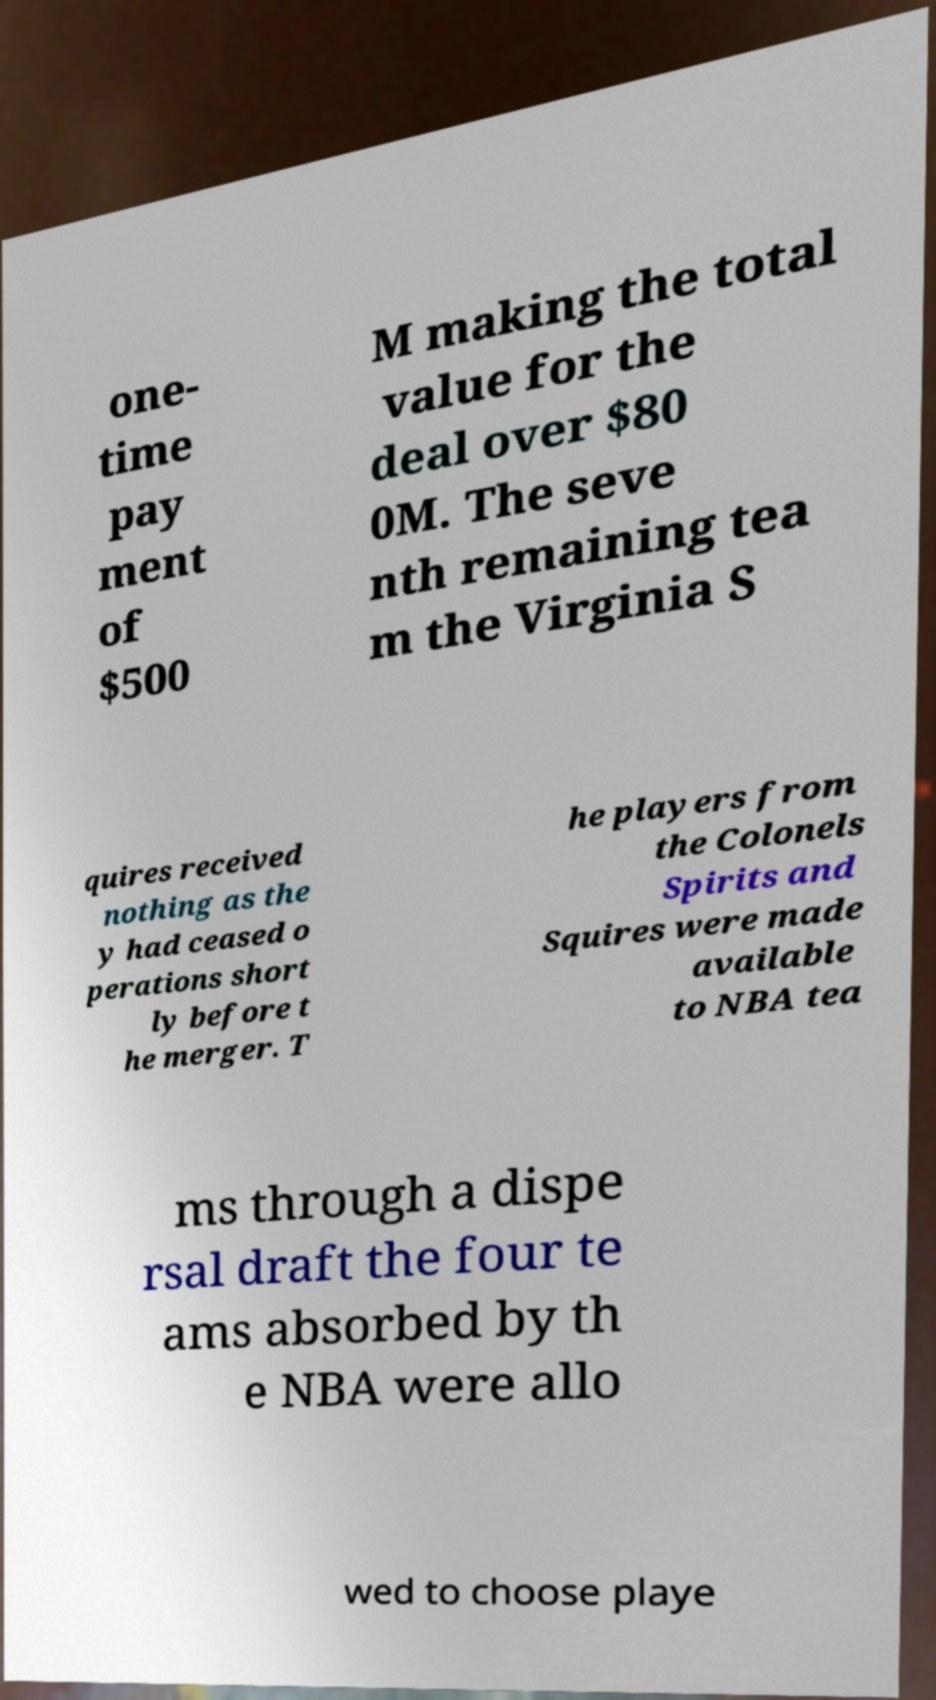For documentation purposes, I need the text within this image transcribed. Could you provide that? one- time pay ment of $500 M making the total value for the deal over $80 0M. The seve nth remaining tea m the Virginia S quires received nothing as the y had ceased o perations short ly before t he merger. T he players from the Colonels Spirits and Squires were made available to NBA tea ms through a dispe rsal draft the four te ams absorbed by th e NBA were allo wed to choose playe 